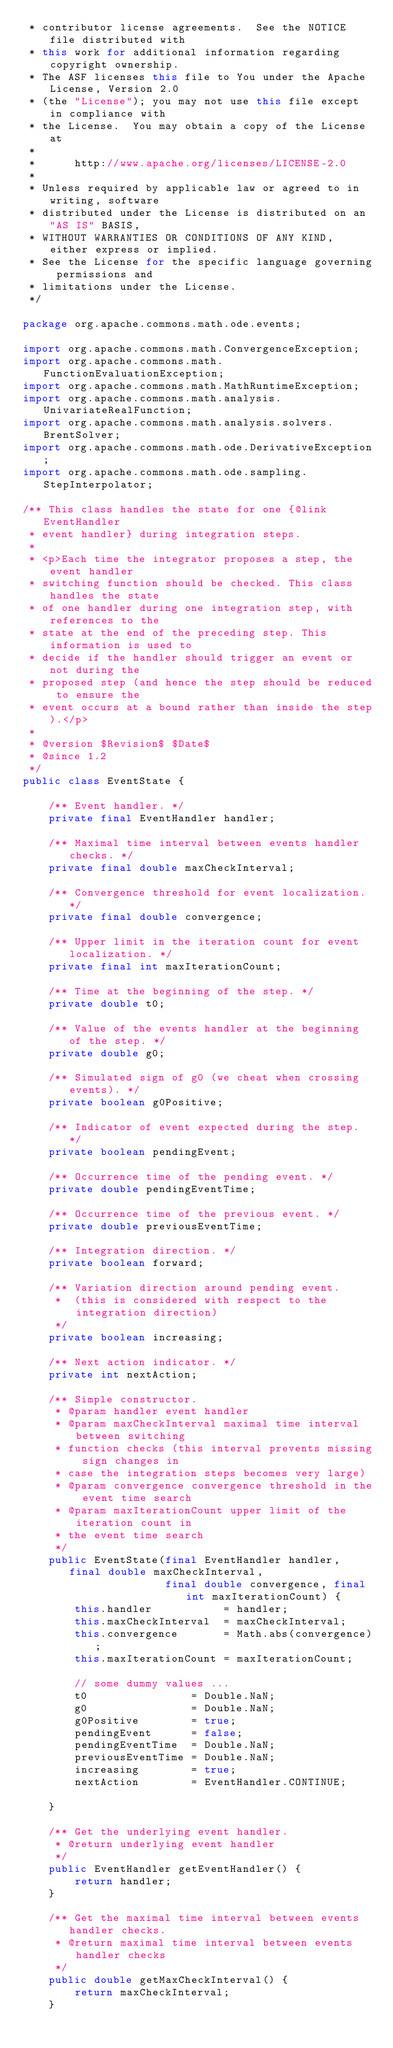Convert code to text. <code><loc_0><loc_0><loc_500><loc_500><_Java_> * contributor license agreements.  See the NOTICE file distributed with
 * this work for additional information regarding copyright ownership.
 * The ASF licenses this file to You under the Apache License, Version 2.0
 * (the "License"); you may not use this file except in compliance with
 * the License.  You may obtain a copy of the License at
 *
 *      http://www.apache.org/licenses/LICENSE-2.0
 *
 * Unless required by applicable law or agreed to in writing, software
 * distributed under the License is distributed on an "AS IS" BASIS,
 * WITHOUT WARRANTIES OR CONDITIONS OF ANY KIND, either express or implied.
 * See the License for the specific language governing permissions and
 * limitations under the License.
 */

package org.apache.commons.math.ode.events;

import org.apache.commons.math.ConvergenceException;
import org.apache.commons.math.FunctionEvaluationException;
import org.apache.commons.math.MathRuntimeException;
import org.apache.commons.math.analysis.UnivariateRealFunction;
import org.apache.commons.math.analysis.solvers.BrentSolver;
import org.apache.commons.math.ode.DerivativeException;
import org.apache.commons.math.ode.sampling.StepInterpolator;

/** This class handles the state for one {@link EventHandler
 * event handler} during integration steps.
 *
 * <p>Each time the integrator proposes a step, the event handler
 * switching function should be checked. This class handles the state
 * of one handler during one integration step, with references to the
 * state at the end of the preceding step. This information is used to
 * decide if the handler should trigger an event or not during the
 * proposed step (and hence the step should be reduced to ensure the
 * event occurs at a bound rather than inside the step).</p>
 *
 * @version $Revision$ $Date$
 * @since 1.2
 */
public class EventState {

    /** Event handler. */
    private final EventHandler handler;

    /** Maximal time interval between events handler checks. */
    private final double maxCheckInterval;

    /** Convergence threshold for event localization. */
    private final double convergence;

    /** Upper limit in the iteration count for event localization. */
    private final int maxIterationCount;

    /** Time at the beginning of the step. */
    private double t0;

    /** Value of the events handler at the beginning of the step. */
    private double g0;

    /** Simulated sign of g0 (we cheat when crossing events). */
    private boolean g0Positive;

    /** Indicator of event expected during the step. */
    private boolean pendingEvent;

    /** Occurrence time of the pending event. */
    private double pendingEventTime;

    /** Occurrence time of the previous event. */
    private double previousEventTime;

    /** Integration direction. */
    private boolean forward;

    /** Variation direction around pending event.
     *  (this is considered with respect to the integration direction)
     */
    private boolean increasing;

    /** Next action indicator. */
    private int nextAction;

    /** Simple constructor.
     * @param handler event handler
     * @param maxCheckInterval maximal time interval between switching
     * function checks (this interval prevents missing sign changes in
     * case the integration steps becomes very large)
     * @param convergence convergence threshold in the event time search
     * @param maxIterationCount upper limit of the iteration count in
     * the event time search
     */
    public EventState(final EventHandler handler, final double maxCheckInterval,
                      final double convergence, final int maxIterationCount) {
        this.handler           = handler;
        this.maxCheckInterval  = maxCheckInterval;
        this.convergence       = Math.abs(convergence);
        this.maxIterationCount = maxIterationCount;

        // some dummy values ...
        t0                = Double.NaN;
        g0                = Double.NaN;
        g0Positive        = true;
        pendingEvent      = false;
        pendingEventTime  = Double.NaN;
        previousEventTime = Double.NaN;
        increasing        = true;
        nextAction        = EventHandler.CONTINUE;

    }

    /** Get the underlying event handler.
     * @return underlying event handler
     */
    public EventHandler getEventHandler() {
        return handler;
    }

    /** Get the maximal time interval between events handler checks.
     * @return maximal time interval between events handler checks
     */
    public double getMaxCheckInterval() {
        return maxCheckInterval;
    }
</code> 